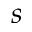Convert formula to latex. <formula><loc_0><loc_0><loc_500><loc_500>s</formula> 